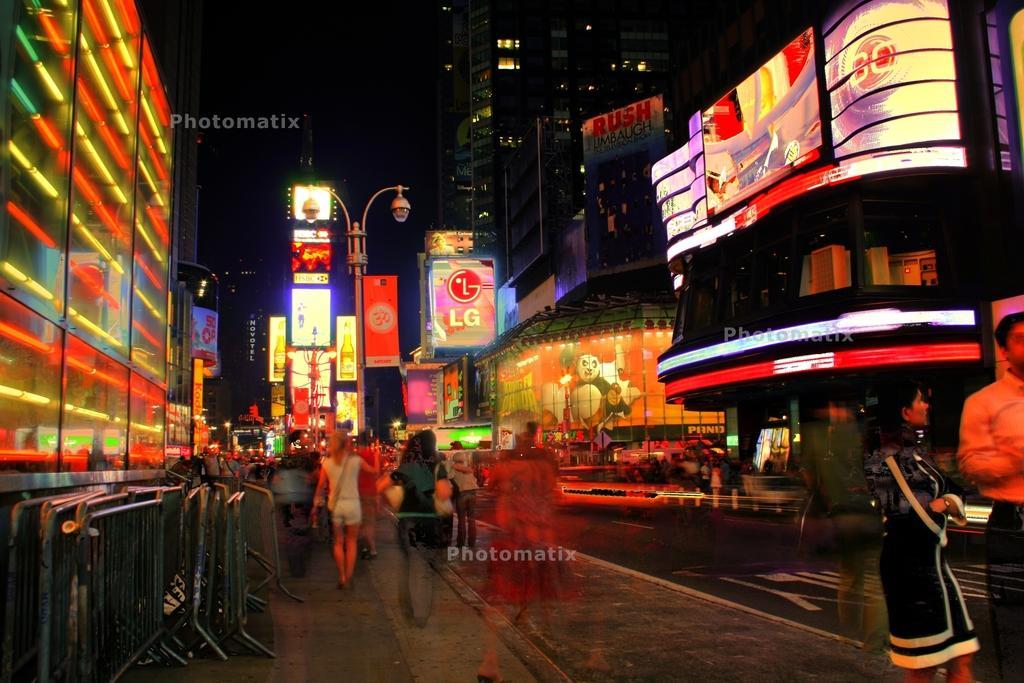Can you describe this image briefly? There are some persons walking on the road as we can see at the bottom of this image, and there are some buildings in the background. There are some display screens present on the buildings. 